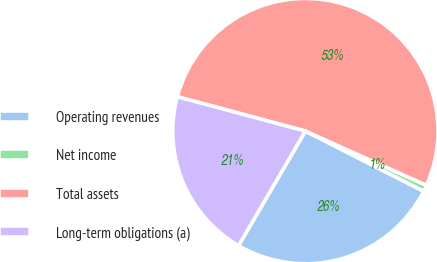<chart> <loc_0><loc_0><loc_500><loc_500><pie_chart><fcel>Operating revenues<fcel>Net income<fcel>Total assets<fcel>Long-term obligations (a)<nl><fcel>25.93%<fcel>0.78%<fcel>52.54%<fcel>20.76%<nl></chart> 